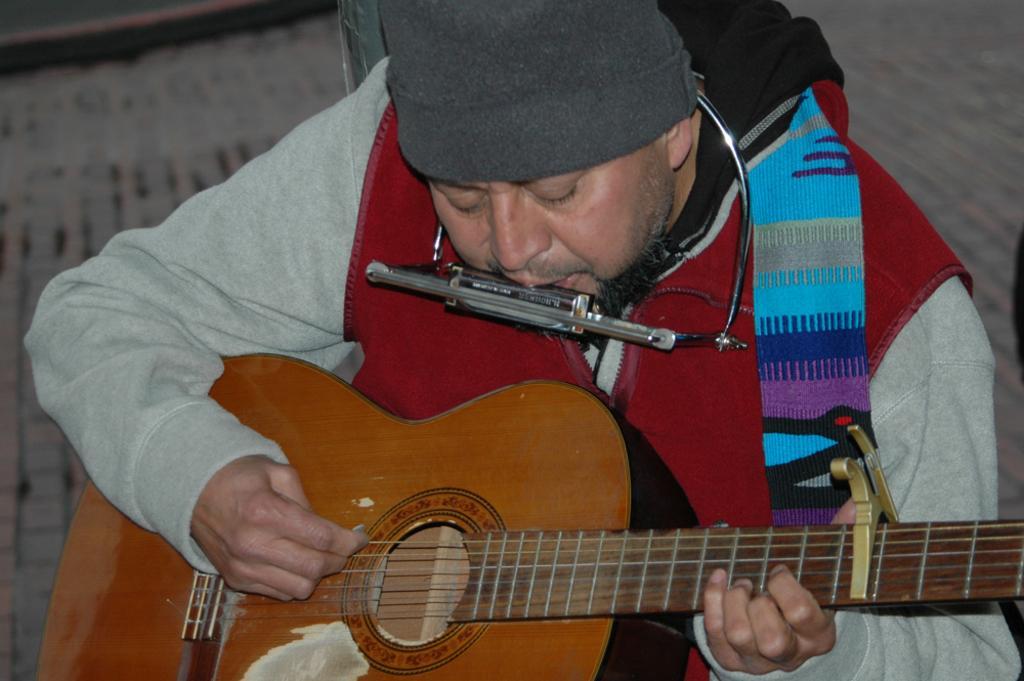Describe this image in one or two sentences. In the image a man is playing a harmonium and also a guitar he is wearing red color jacket. 